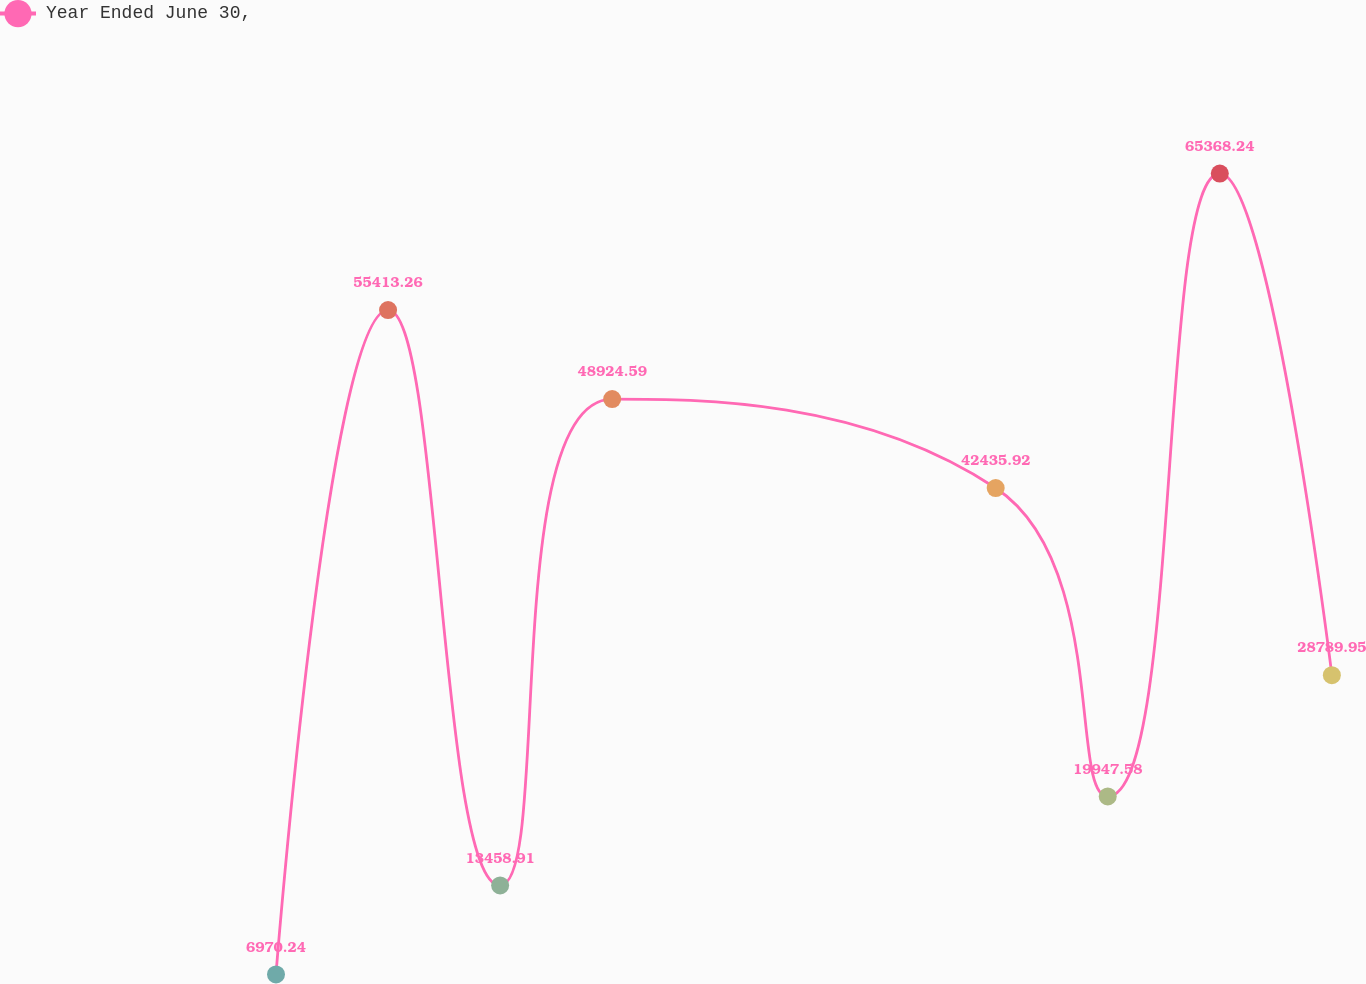Convert chart to OTSL. <chart><loc_0><loc_0><loc_500><loc_500><line_chart><ecel><fcel>Year Ended June 30,<nl><fcel>683.03<fcel>6970.24<nl><fcel>7262.53<fcel>55413.3<nl><fcel>13842<fcel>13458.9<nl><fcel>20421.5<fcel>48924.6<nl><fcel>42936.8<fcel>42435.9<nl><fcel>49516.2<fcel>19947.6<nl><fcel>56095.8<fcel>65368.2<nl><fcel>62675.2<fcel>28790<nl><fcel>69254.8<fcel>481.57<nl><fcel>75834.2<fcel>35278.6<nl></chart> 